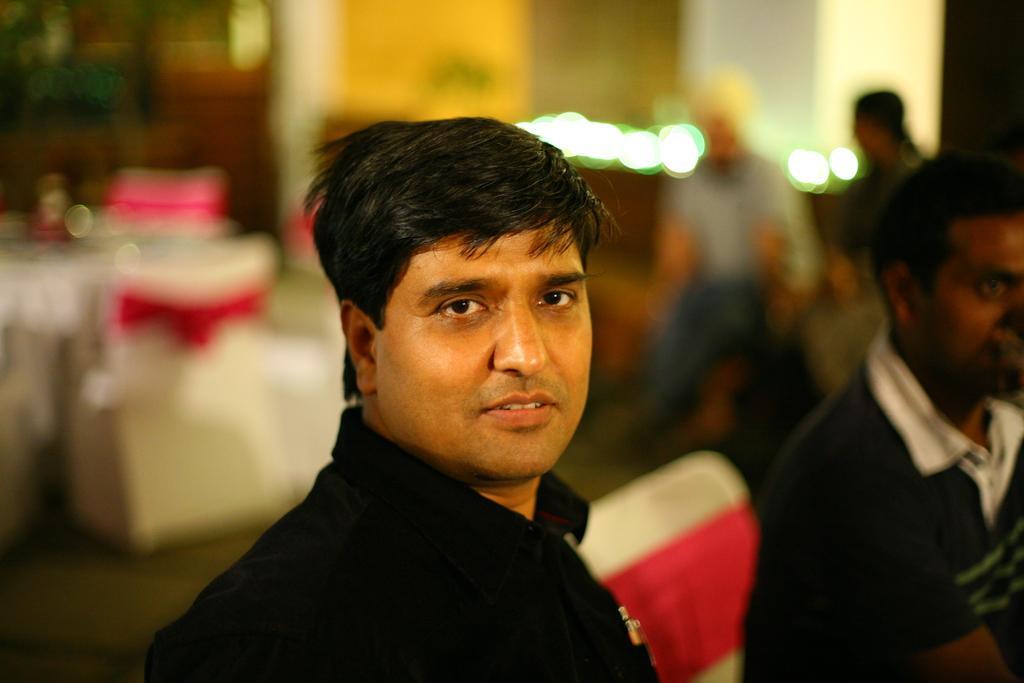In one or two sentences, can you explain what this image depicts? In this image we can see a man. On the backside we can see a table and some chairs which are decorated with the cloth. We can also see some people sitting and a wall. 